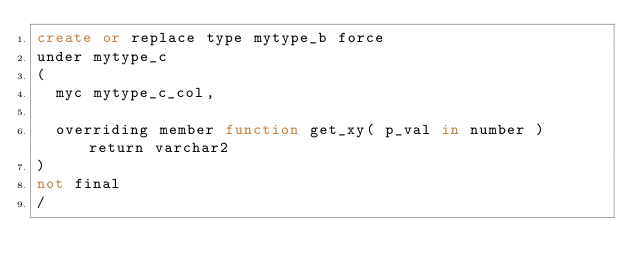Convert code to text. <code><loc_0><loc_0><loc_500><loc_500><_SQL_>create or replace type mytype_b force
under mytype_c
(
  myc mytype_c_col,

  overriding member function get_xy( p_val in number ) return varchar2
)
not final
/
</code> 